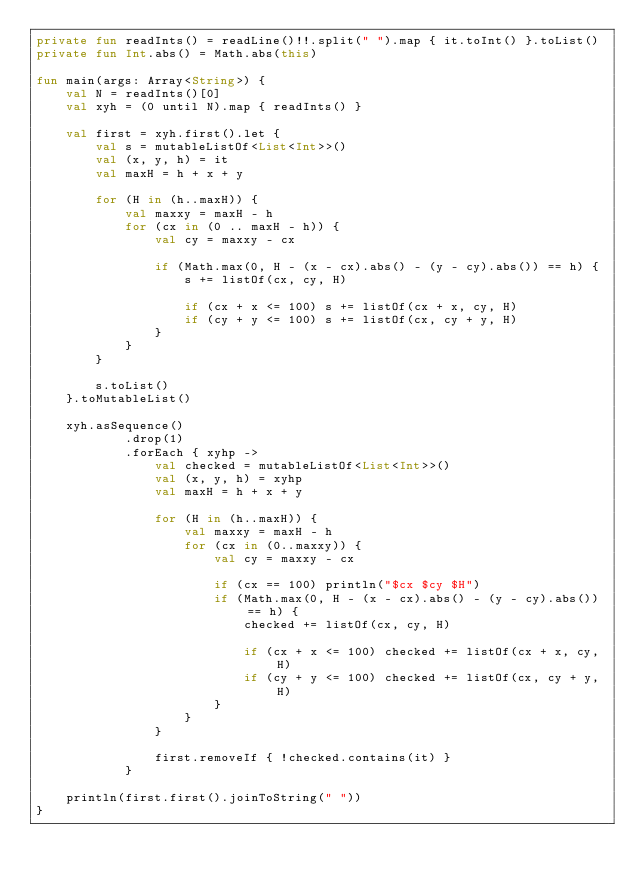<code> <loc_0><loc_0><loc_500><loc_500><_Kotlin_>private fun readInts() = readLine()!!.split(" ").map { it.toInt() }.toList()
private fun Int.abs() = Math.abs(this)

fun main(args: Array<String>) {
    val N = readInts()[0]
    val xyh = (0 until N).map { readInts() }

    val first = xyh.first().let {
        val s = mutableListOf<List<Int>>()
        val (x, y, h) = it
        val maxH = h + x + y

        for (H in (h..maxH)) {
            val maxxy = maxH - h
            for (cx in (0 .. maxH - h)) {
                val cy = maxxy - cx

                if (Math.max(0, H - (x - cx).abs() - (y - cy).abs()) == h) {
                    s += listOf(cx, cy, H)

                    if (cx + x <= 100) s += listOf(cx + x, cy, H)
                    if (cy + y <= 100) s += listOf(cx, cy + y, H)
                }
            }
        }

        s.toList()
    }.toMutableList()

    xyh.asSequence()
            .drop(1)
            .forEach { xyhp ->
                val checked = mutableListOf<List<Int>>()
                val (x, y, h) = xyhp
                val maxH = h + x + y

                for (H in (h..maxH)) {
                    val maxxy = maxH - h
                    for (cx in (0..maxxy)) {
                        val cy = maxxy - cx

                        if (cx == 100) println("$cx $cy $H")
                        if (Math.max(0, H - (x - cx).abs() - (y - cy).abs()) == h) {
                            checked += listOf(cx, cy, H)

                            if (cx + x <= 100) checked += listOf(cx + x, cy, H)
                            if (cy + y <= 100) checked += listOf(cx, cy + y, H)
                        }
                    }
                }

                first.removeIf { !checked.contains(it) }
            }

    println(first.first().joinToString(" "))
}</code> 